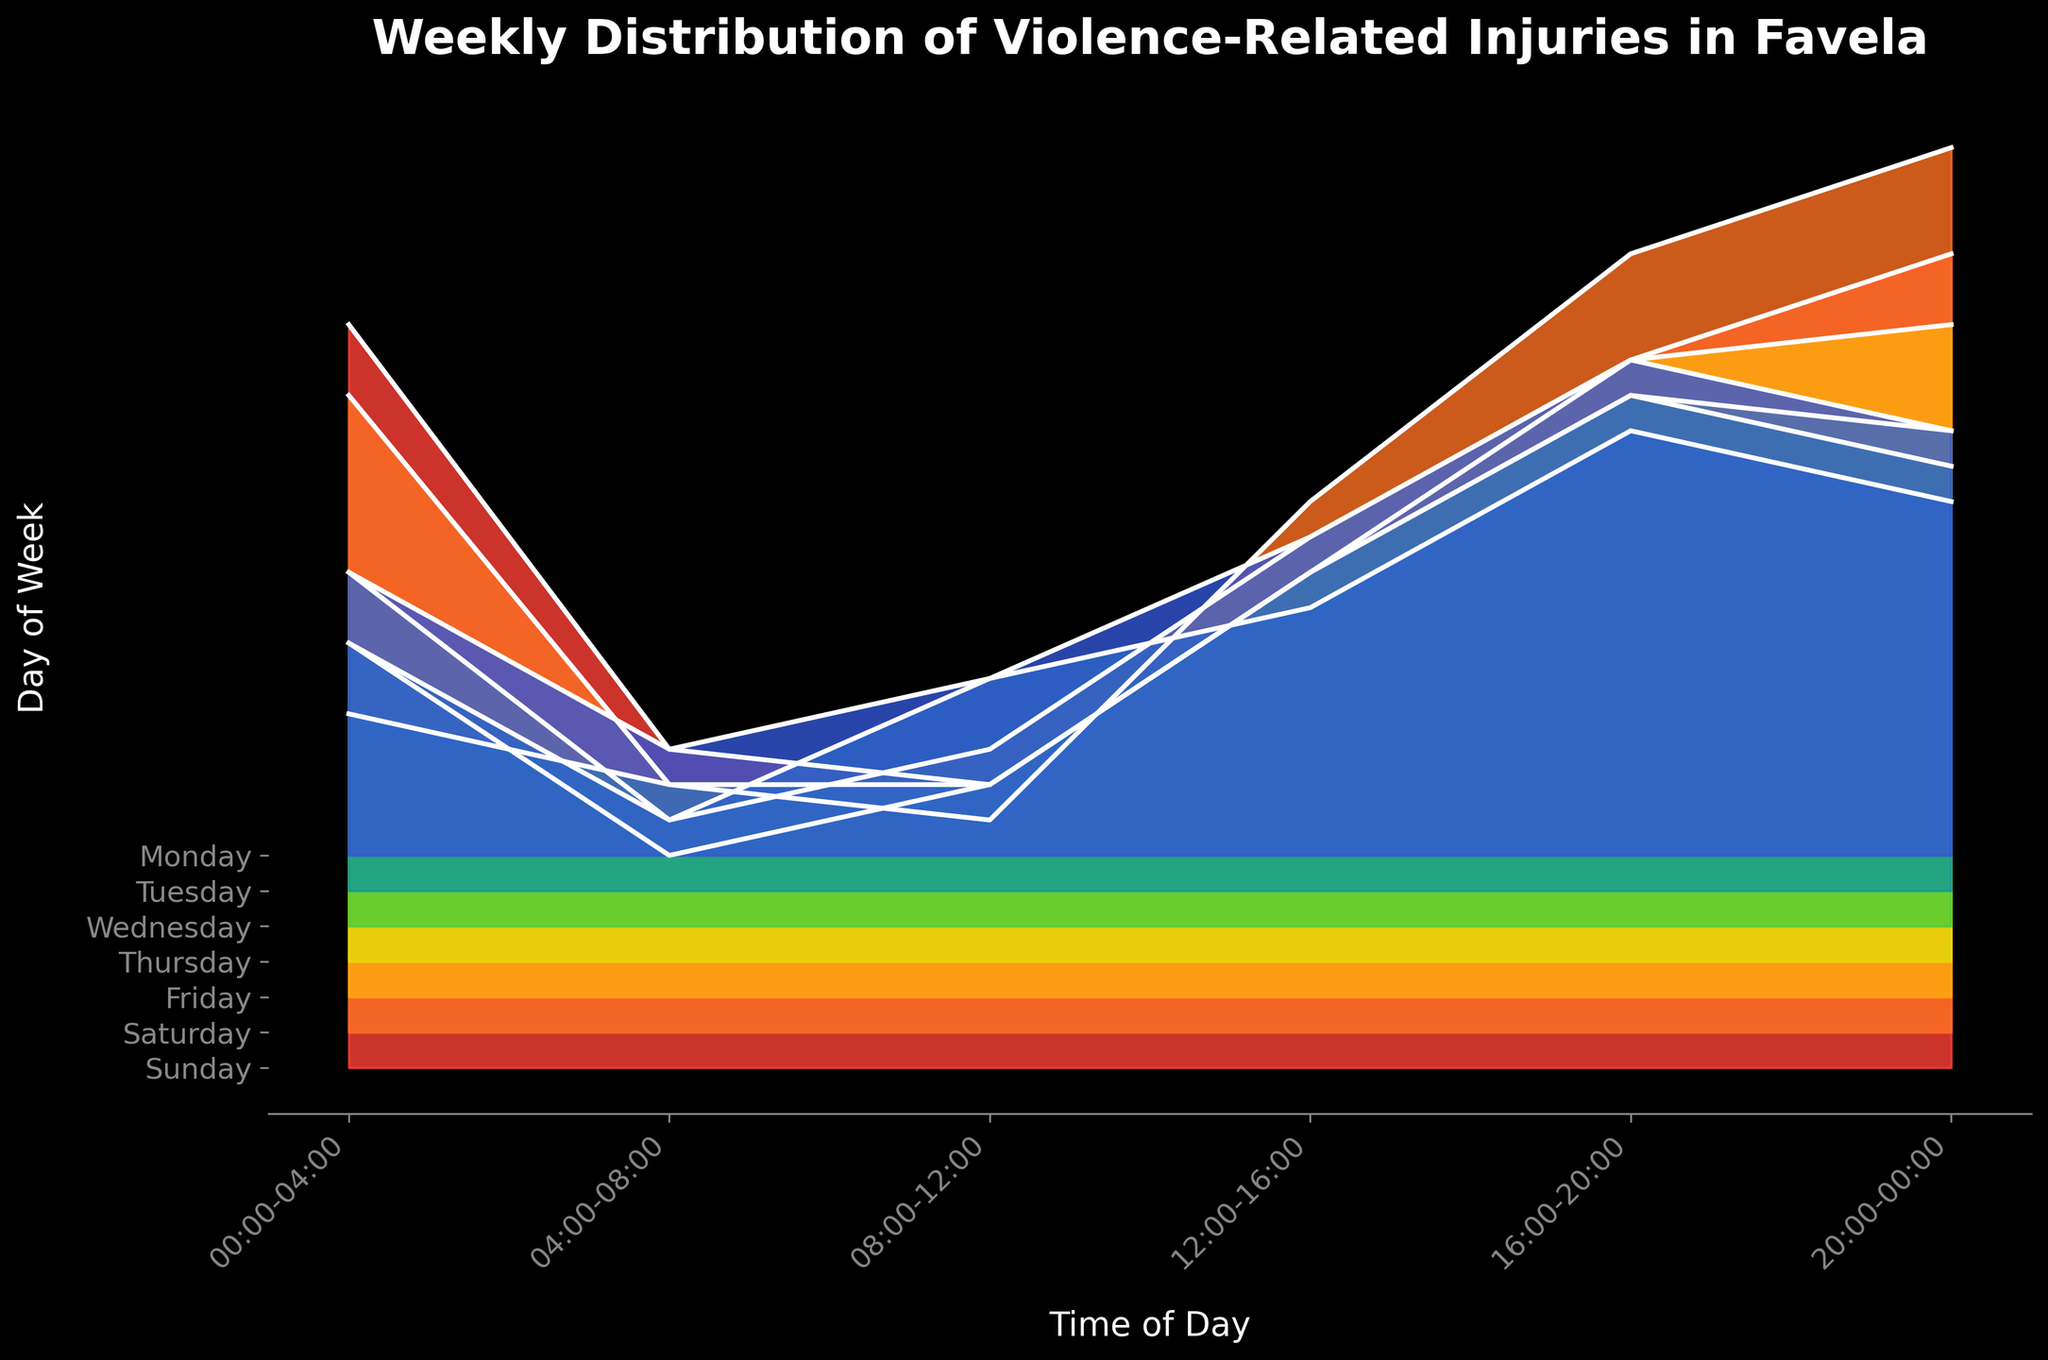What is the title of the figure? The title of a plot is usually displayed at the top of the figure. In this case, it reads "Weekly Distribution of Violence-Related Injuries in Favela."
Answer: Weekly Distribution of Violence-Related Injuries in Favela What are the time intervals shown on the x-axis? The time intervals are represented along the x-axis and labeled horizontally. They read as "00:00-04:00," "04:00-08:00," "08:00-12:00," "12:00-16:00," "16:00-20:00," and "20:00-00:00."
Answer: 00:00-04:00, 04:00-08:00, 08:00-12:00, 12:00-16:00, 16:00-20:00, 20:00-00:00 Which day has the highest number of injuries reported between 16:00 and 20:00? To find the day with the highest number of injuries in this time interval, look at the peak values for "16:00-20:00" across the days. Sunday has the highest peak.
Answer: Sunday During which time interval are the injuries consistently low across all days? Consistency of low injuries can be identified by comparing the heights of the ridgelines in each time interval. The interval "04:00-08:00" has the lowest and most consistent ridgelines across all days.
Answer: 04:00-08:00 What is the approximate number of injuries reported on Saturday between 20:00 and 00:00? Look at the height of the ridgeline for Saturday during the "20:00-00:00" interval. The height corresponds to 25.
Answer: 25 Which day shows a noticeable rise in injuries after 12:00? To find this, examine the height increases after 12:00. Saturday shows a noticeable rise in injuries after this time interval.
Answer: Saturday How do the number of injuries reported on Friday between 12:00 and 16:00 compare with those reported on Monday in the same time interval? Look at the heights of the ridgelines for Friday and Monday between 12:00 and 16:00. Friday has a higher peak than Monday.
Answer: Higher on Friday Which two time intervals on Sunday have nearly equal reported injuries? Compare the peak heights of the ridgelines on Sunday for all intervals. The intervals "12:00-16:00" and "16:00-20:00" have nearly equal heights.
Answer: 12:00-16:00 and 16:00-20:00 Between which two consecutive days is there the greatest change in injuries for the interval 00:00-04:00? Find the greatest change by comparing the differences in peak heights for adjacent days within the "00:00-04:00" interval. The greatest change is between Friday and Saturday.
Answer: Friday and Saturday 